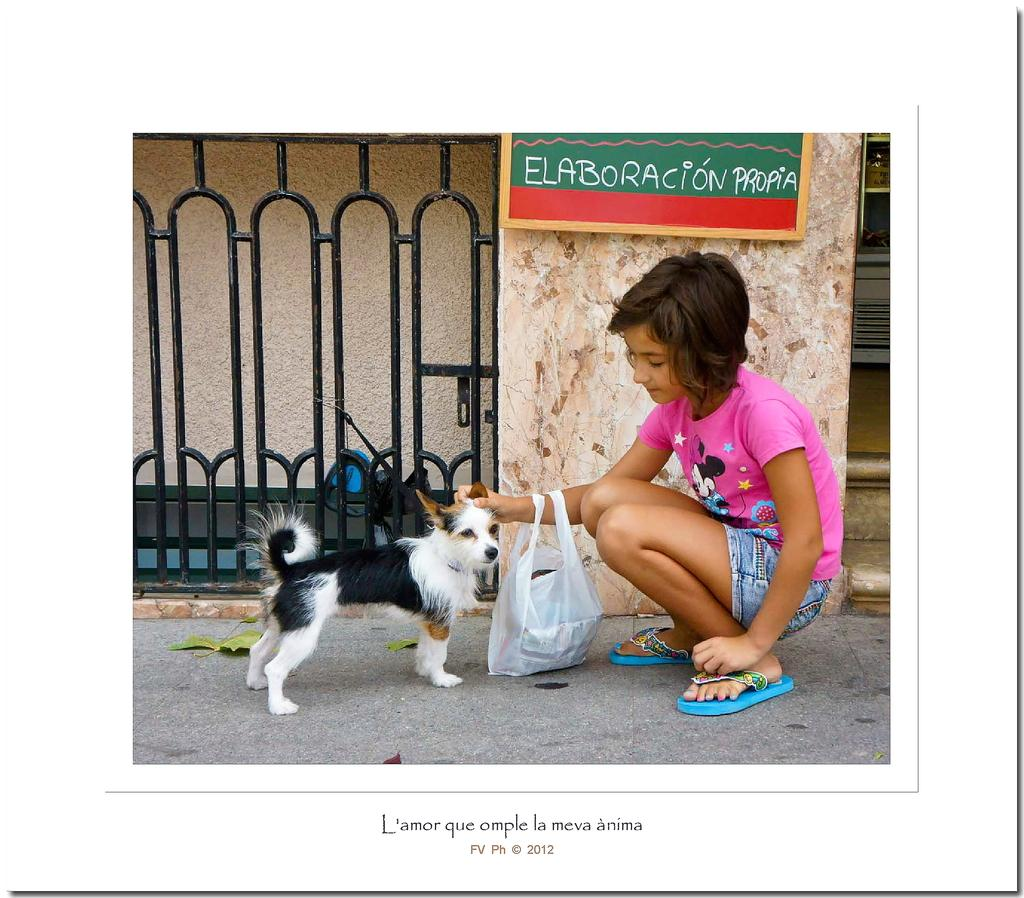Who is the main subject in the image? There is a girl in the image. What is the girl holding in the image? The girl is holding a cover. What is the girl doing with the dog in the image? The girl is sitting in front of a dog and petting it. What can be seen in the background of the image? There is a gate and a wall in the background of the image. What is attached to the wall in the background? A board is attached to the wall. What type of tank is visible in the image? There is no tank present in the image. What advice does the minister give to the girl in the image? There is no minister present in the image, so no advice can be given. 